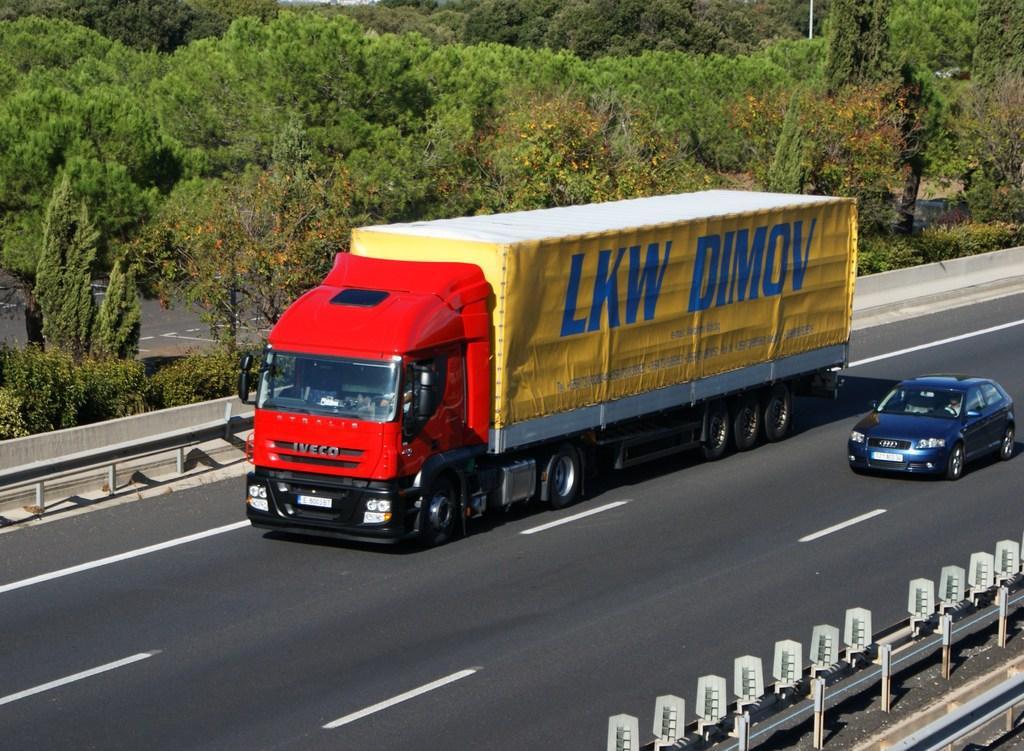Could you give a brief overview of what you see in this image? In the middle of the image a truck is moving on the road beside there is a car in which a person is sitting inside the car. At the background there is full of trees. Both sides of the road there is fence. 